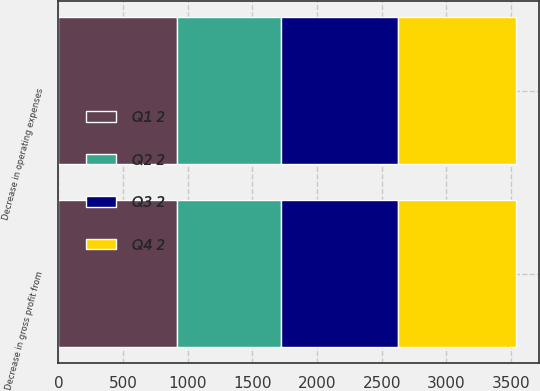<chart> <loc_0><loc_0><loc_500><loc_500><stacked_bar_chart><ecel><fcel>Decrease in gross profit from<fcel>Decrease in operating expenses<nl><fcel>Q3 2<fcel>904<fcel>904<nl><fcel>Q1 2<fcel>919<fcel>919<nl><fcel>Q2 2<fcel>803<fcel>803<nl><fcel>Q4 2<fcel>911<fcel>911<nl></chart> 